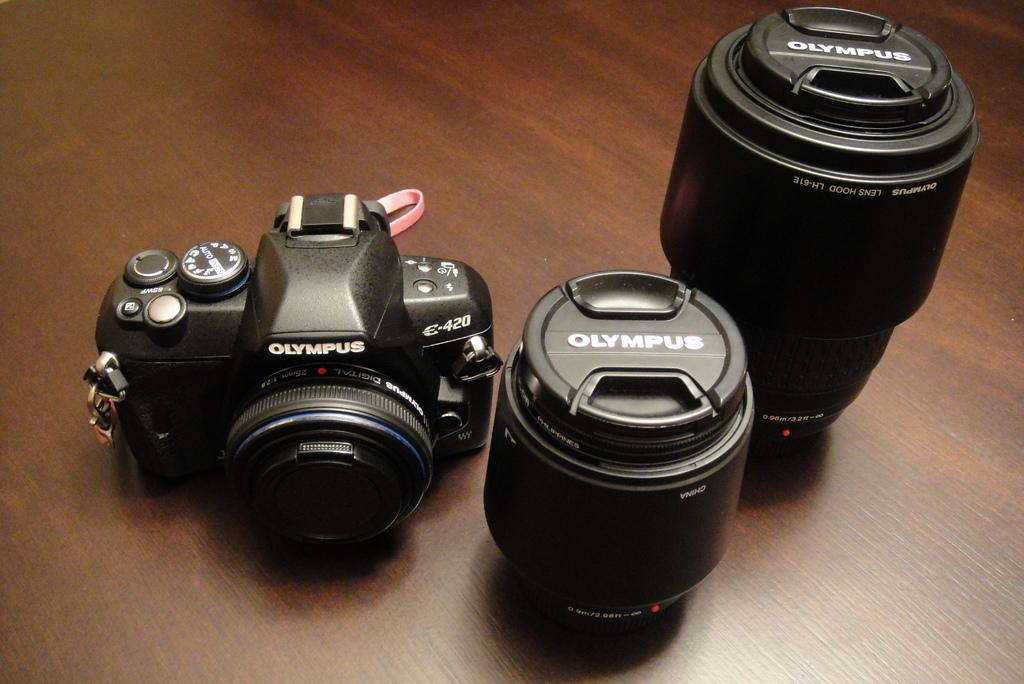What is the main subject in the foreground of the image? There is a camera in the foreground of the image. What types of lenses are visible in the foreground of the image? There is a short lens and a long lens in the foreground of the image. Where are the camera and lenses placed in the image? All the mentioned items are placed on a surface. What type of cord is connected to the camera in the image? There is no cord connected to the camera in the image. 